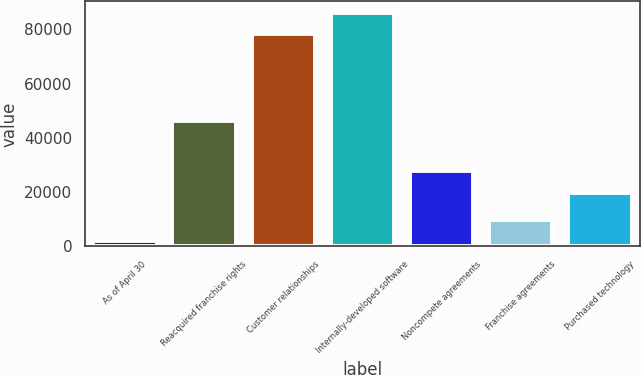Convert chart to OTSL. <chart><loc_0><loc_0><loc_500><loc_500><bar_chart><fcel>As of April 30<fcel>Reacquired franchise rights<fcel>Customer relationships<fcel>Internally-developed software<fcel>Noncompete agreements<fcel>Franchise agreements<fcel>Purchased technology<nl><fcel>2015<fcel>46180<fcel>78157<fcel>86024.4<fcel>27713.4<fcel>9882.4<fcel>19846<nl></chart> 